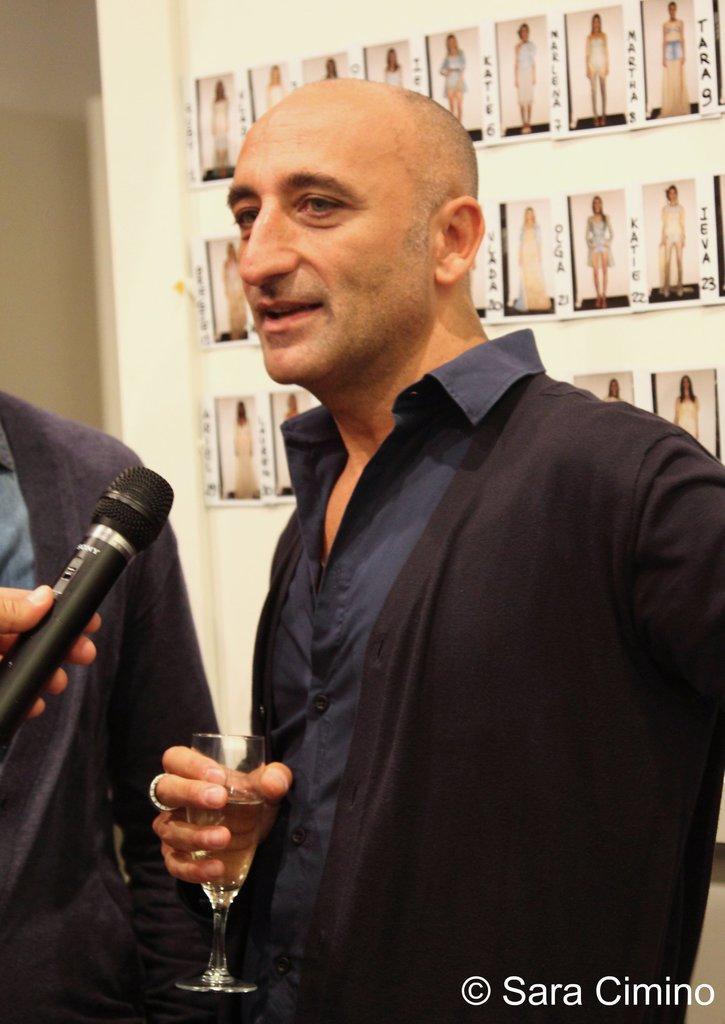Can you describe this image briefly? In this image there are three persons standing on the floor. At the back side there is a wall where photo frames are attached to the wall. 